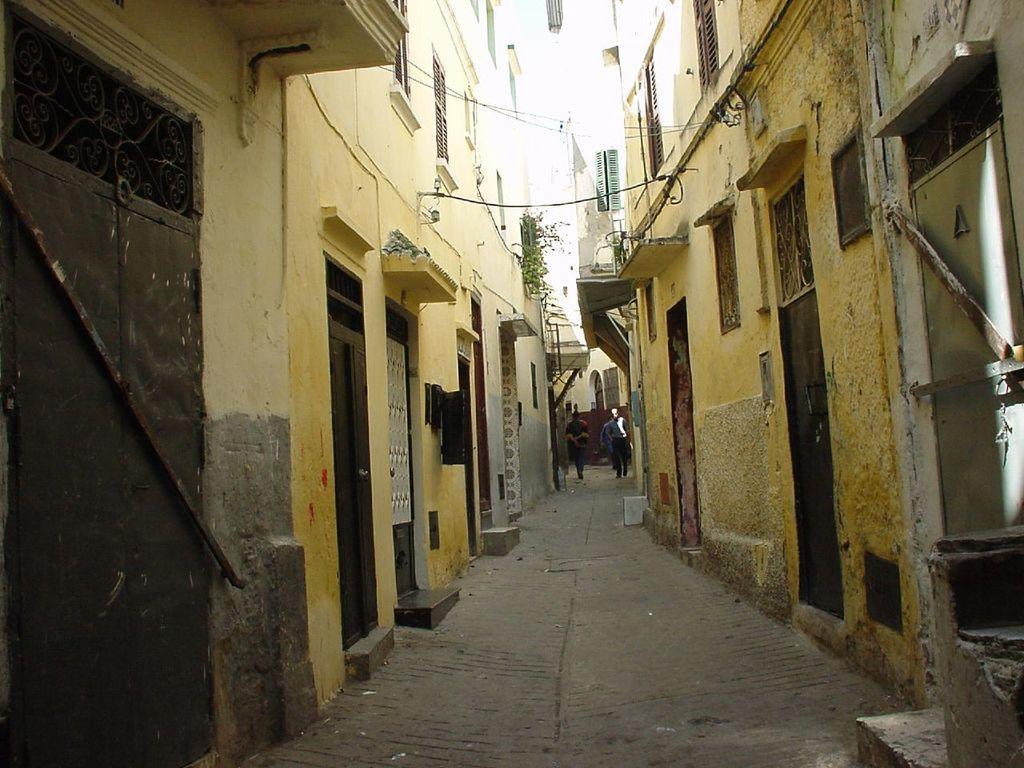Could you give a brief overview of what you see in this image? In this image in the middle there is a path. On the path few people are moving. On both sides of the path there are buildings. These are doors, these are the windows. 